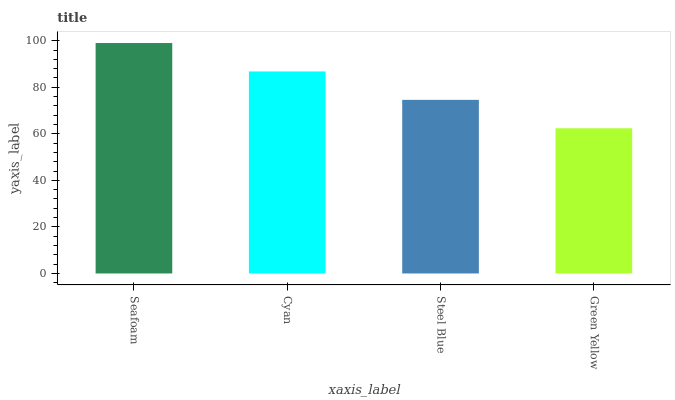Is Green Yellow the minimum?
Answer yes or no. Yes. Is Seafoam the maximum?
Answer yes or no. Yes. Is Cyan the minimum?
Answer yes or no. No. Is Cyan the maximum?
Answer yes or no. No. Is Seafoam greater than Cyan?
Answer yes or no. Yes. Is Cyan less than Seafoam?
Answer yes or no. Yes. Is Cyan greater than Seafoam?
Answer yes or no. No. Is Seafoam less than Cyan?
Answer yes or no. No. Is Cyan the high median?
Answer yes or no. Yes. Is Steel Blue the low median?
Answer yes or no. Yes. Is Seafoam the high median?
Answer yes or no. No. Is Seafoam the low median?
Answer yes or no. No. 